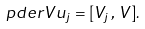<formula> <loc_0><loc_0><loc_500><loc_500>\ p d e r { V } { u _ { j } } = [ V _ { j } \, , \, V ] .</formula> 